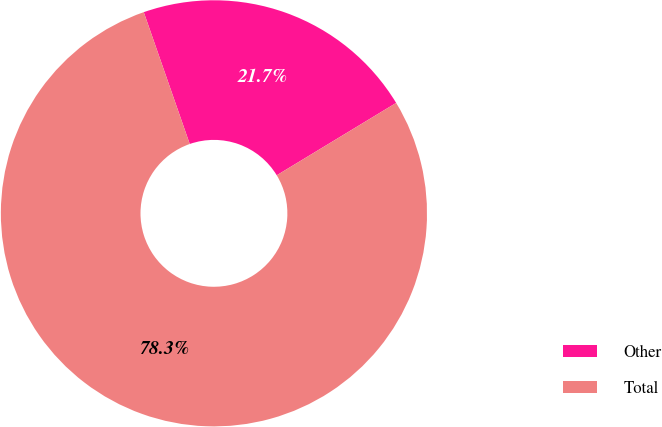Convert chart. <chart><loc_0><loc_0><loc_500><loc_500><pie_chart><fcel>Other<fcel>Total<nl><fcel>21.67%<fcel>78.33%<nl></chart> 